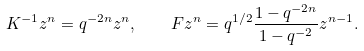Convert formula to latex. <formula><loc_0><loc_0><loc_500><loc_500>K ^ { - 1 } z ^ { n } = q ^ { - 2 n } z ^ { n } , \quad F z ^ { n } = q ^ { 1 / 2 } \frac { 1 - q ^ { - 2 n } } { 1 - q ^ { - 2 } } z ^ { n - 1 } .</formula> 